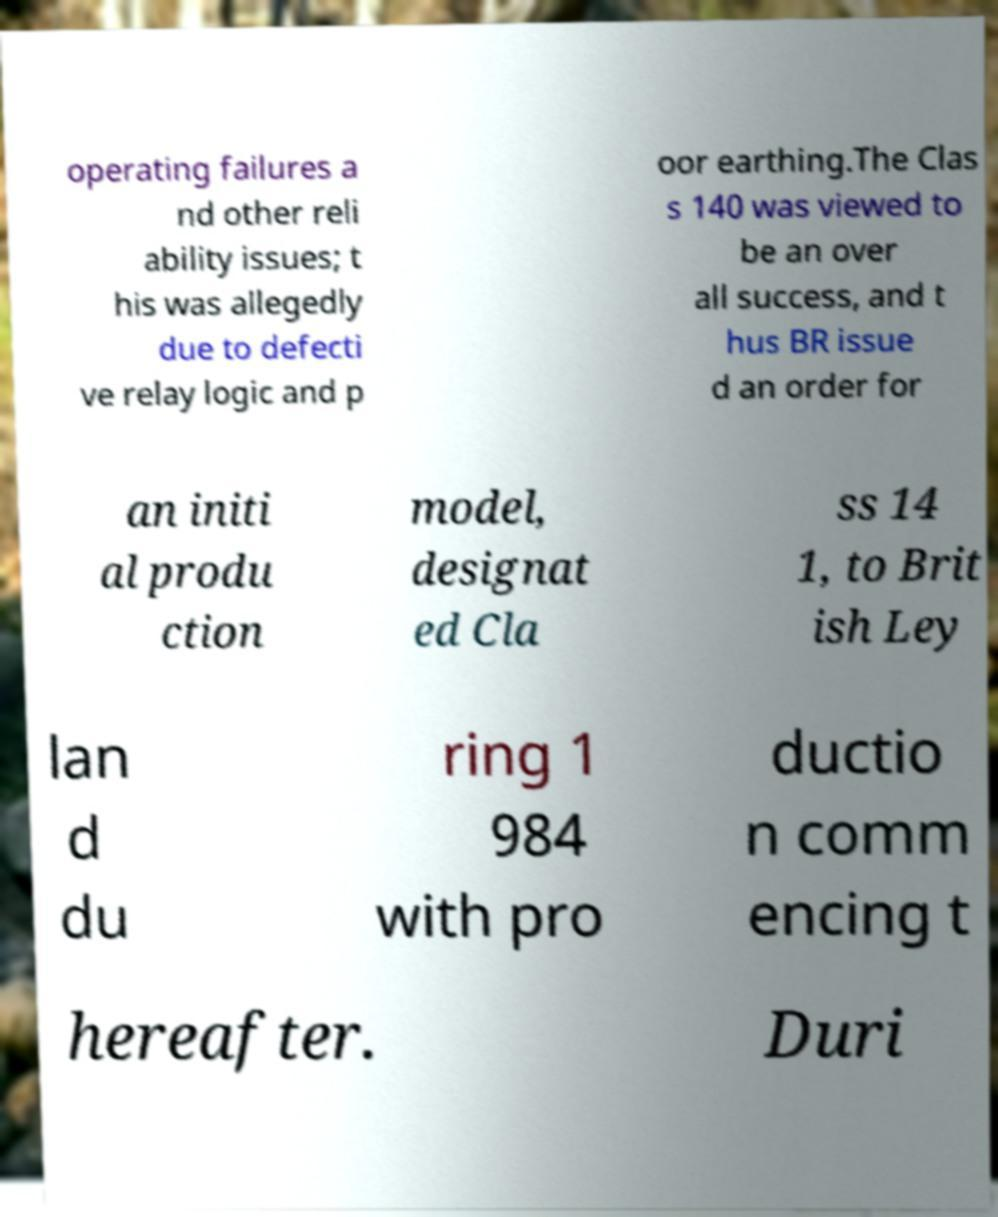Could you extract and type out the text from this image? operating failures a nd other reli ability issues; t his was allegedly due to defecti ve relay logic and p oor earthing.The Clas s 140 was viewed to be an over all success, and t hus BR issue d an order for an initi al produ ction model, designat ed Cla ss 14 1, to Brit ish Ley lan d du ring 1 984 with pro ductio n comm encing t hereafter. Duri 